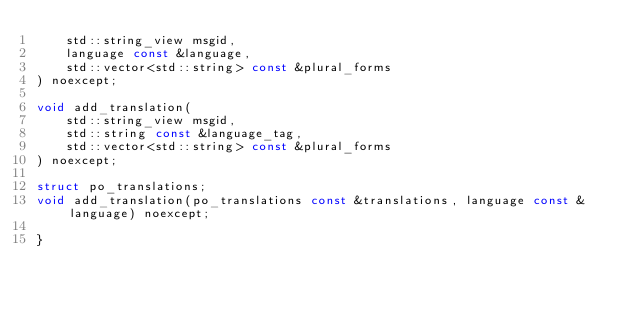Convert code to text. <code><loc_0><loc_0><loc_500><loc_500><_C++_>    std::string_view msgid,
    language const &language,
    std::vector<std::string> const &plural_forms
) noexcept;

void add_translation(
    std::string_view msgid,
    std::string const &language_tag,
    std::vector<std::string> const &plural_forms
) noexcept;

struct po_translations;
void add_translation(po_translations const &translations, language const &language) noexcept;

}
</code> 